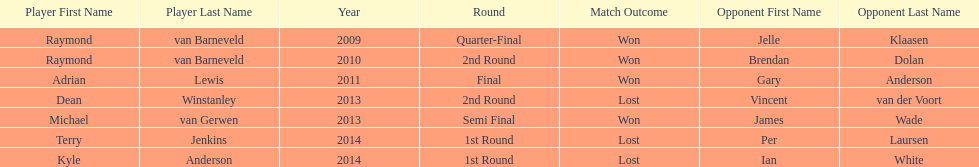Who won the first world darts championship? Raymond van Barneveld. 